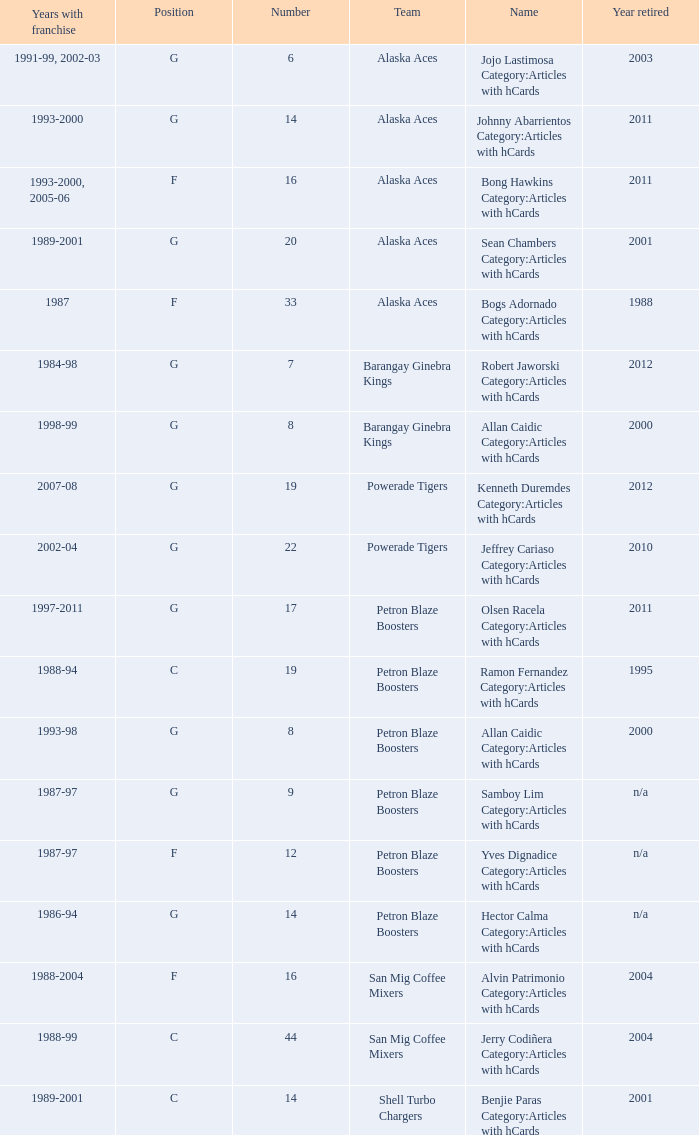How many years did the team in slot number 9 have a franchise? 1987-97. 